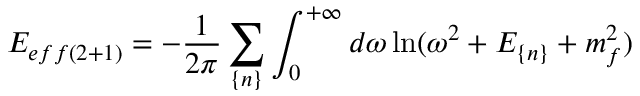Convert formula to latex. <formula><loc_0><loc_0><loc_500><loc_500>E _ { e f f ( 2 + 1 ) } = - \frac { 1 } { 2 \pi } \sum _ { \{ n \} } \int _ { 0 } ^ { + \infty } d \omega \ln ( \omega ^ { 2 } + E _ { \{ n \} } + m _ { f } ^ { 2 } )</formula> 